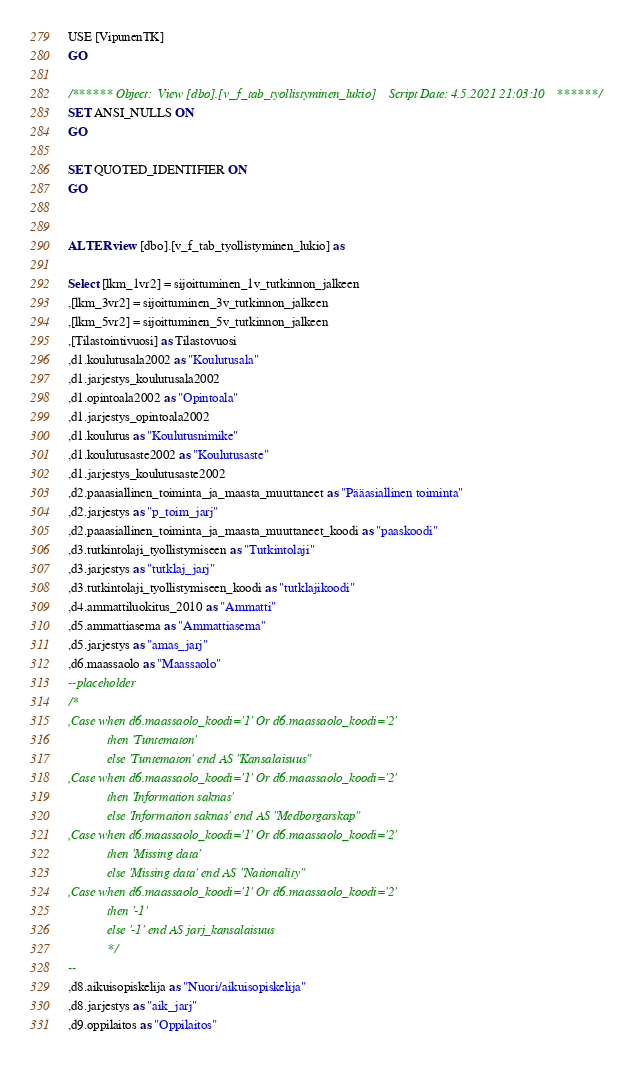Convert code to text. <code><loc_0><loc_0><loc_500><loc_500><_SQL_>USE [VipunenTK]
GO

/****** Object:  View [dbo].[v_f_tab_tyollistyminen_lukio]    Script Date: 4.5.2021 21:03:10 ******/
SET ANSI_NULLS ON
GO

SET QUOTED_IDENTIFIER ON
GO


ALTER view [dbo].[v_f_tab_tyollistyminen_lukio] as

Select [lkm_1vr2] = sijoittuminen_1v_tutkinnon_jalkeen
,[lkm_3vr2] = sijoittuminen_3v_tutkinnon_jalkeen
,[lkm_5vr2] = sijoittuminen_5v_tutkinnon_jalkeen
,[Tilastointivuosi] as Tilastovuosi
,d1.koulutusala2002 as "Koulutusala"
,d1.jarjestys_koulutusala2002
,d1.opintoala2002 as "Opintoala"
,d1.jarjestys_opintoala2002
,d1.koulutus as "Koulutusnimike"
,d1.koulutusaste2002 as "Koulutusaste"
,d1.jarjestys_koulutusaste2002
,d2.paaasiallinen_toiminta_ja_maasta_muuttaneet as "Pääasiallinen toiminta"
,d2.jarjestys as "p_toim_jarj"
,d2.paaasiallinen_toiminta_ja_maasta_muuttaneet_koodi as "paaskoodi"
,d3.tutkintolaji_tyollistymiseen as "Tutkintolaji"
,d3.jarjestys as "tutklaj_jarj"
,d3.tutkintolaji_tyollistymiseen_koodi as "tutklajikoodi"
,d4.ammattiluokitus_2010 as "Ammatti"
,d5.ammattiasema as "Ammattiasema"
,d5.jarjestys as "amas_jarj"
,d6.maassaolo as "Maassaolo"
--placeholder
/*
,Case when d6.maassaolo_koodi='1' Or d6.maassaolo_koodi='2'
			then 'Tuntematon'
			else 'Tuntematon' end AS "Kansalaisuus"
,Case when d6.maassaolo_koodi='1' Or d6.maassaolo_koodi='2'
			then 'Information saknas'
			else 'Information saknas' end AS "Medborgarskap"
,Case when d6.maassaolo_koodi='1' Or d6.maassaolo_koodi='2'
			then 'Missing data'
			else 'Missing data' end AS "Nationality"
,Case when d6.maassaolo_koodi='1' Or d6.maassaolo_koodi='2'
			then '-1'
			else '-1' end AS jarj_kansalaisuus
			*/
--
,d8.aikuisopiskelija as "Nuori/aikuisopiskelija"
,d8.jarjestys as "aik_jarj"
,d9.oppilaitos as "Oppilaitos"</code> 